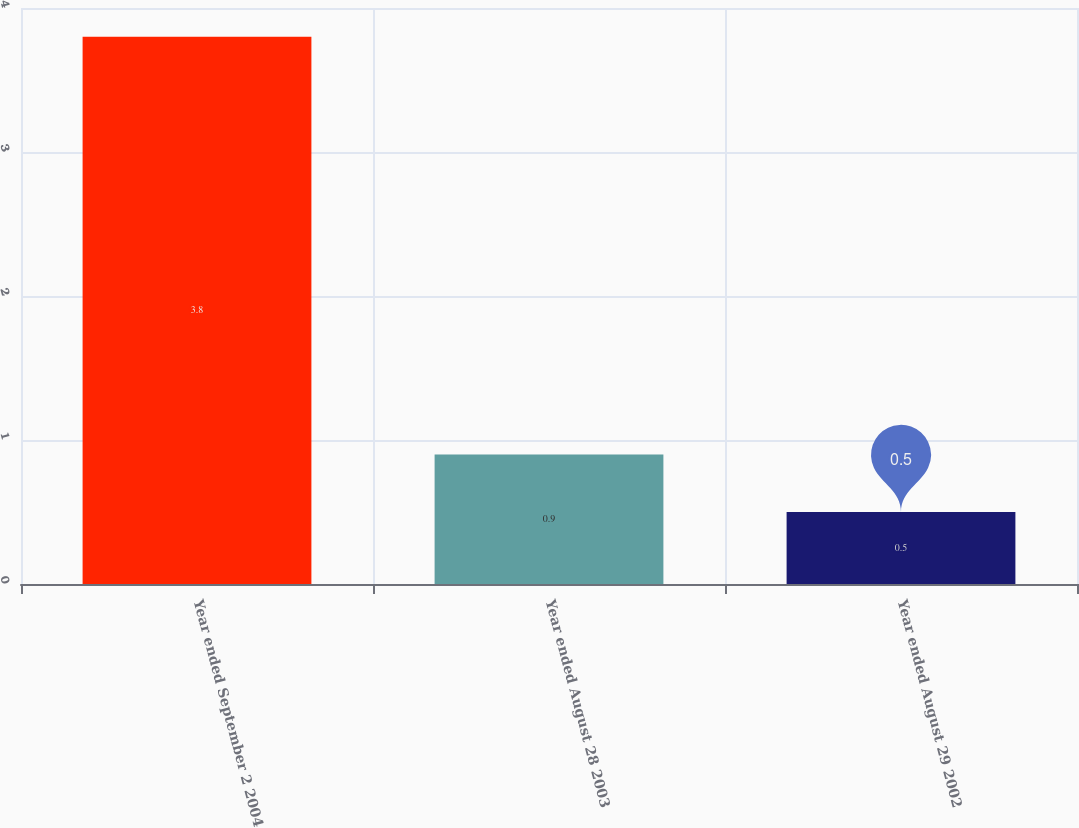Convert chart. <chart><loc_0><loc_0><loc_500><loc_500><bar_chart><fcel>Year ended September 2 2004<fcel>Year ended August 28 2003<fcel>Year ended August 29 2002<nl><fcel>3.8<fcel>0.9<fcel>0.5<nl></chart> 